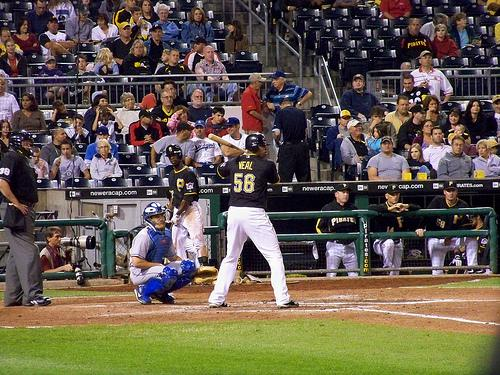Question: what color is the grass?
Choices:
A. Black.
B. Yellow.
C. Green.
D. Brown.
Answer with the letter. Answer: C Question: what color is the bat?
Choices:
A. Metallic.
B. Red.
C. Tan.
D. White.
Answer with the letter. Answer: C Question: who is holding the bat?
Choices:
A. The man in the helmet on the right.
B. The runner.
C. The coach.
D. The pitcher.
Answer with the letter. Answer: A Question: where was the picture taken?
Choices:
A. On a basketball court.
B. In a football stadium.
C. At a baseball field.
D. At the ice rink.
Answer with the letter. Answer: C 